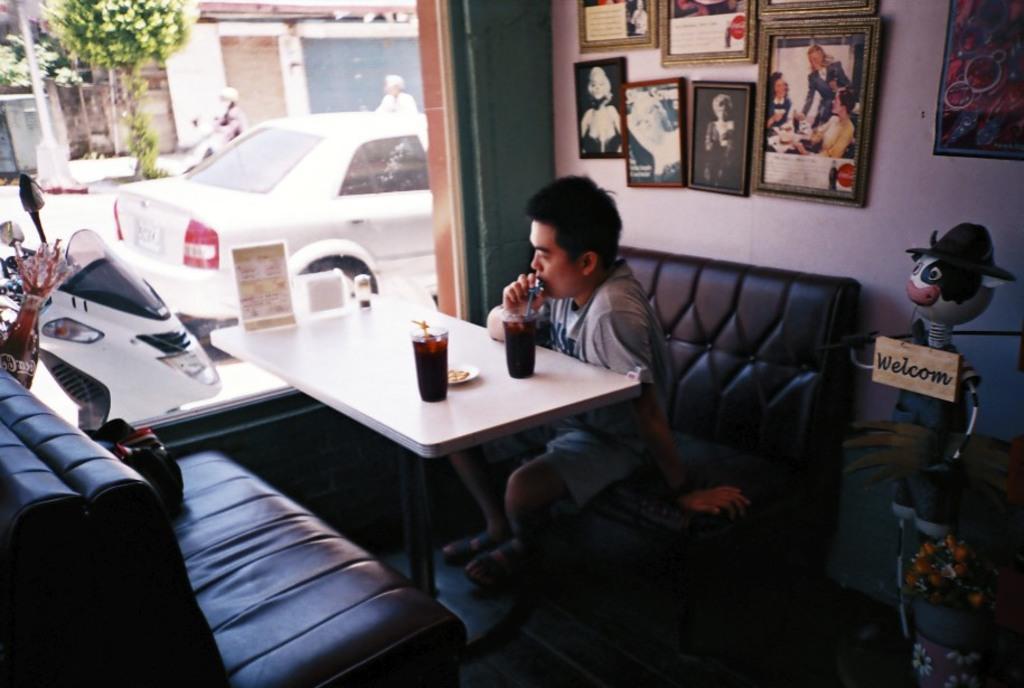Describe this image in one or two sentences. In the middle of the image there is table, On the table there is a glass. Bottom right side of the image there is couch. Top right side of the image there are photo frames hanging on the wall. Right side of the image there is a doll standing. Left side of the image there is a bike. Top left side of the image there is a tree. In the middle of the image a car is going on the road. Behind the car a woman is riding a vehicle. 